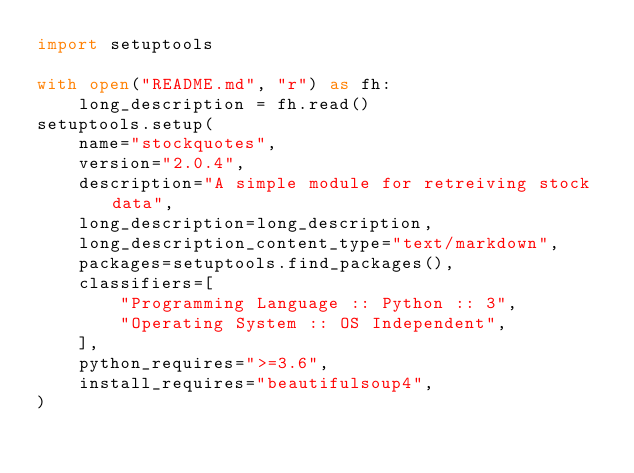Convert code to text. <code><loc_0><loc_0><loc_500><loc_500><_Python_>import setuptools

with open("README.md", "r") as fh:
    long_description = fh.read()
setuptools.setup(
    name="stockquotes",
    version="2.0.4",
    description="A simple module for retreiving stock data",
    long_description=long_description,
    long_description_content_type="text/markdown",
    packages=setuptools.find_packages(),
    classifiers=[
        "Programming Language :: Python :: 3",
        "Operating System :: OS Independent",
    ],
    python_requires=">=3.6",
    install_requires="beautifulsoup4",
)
</code> 